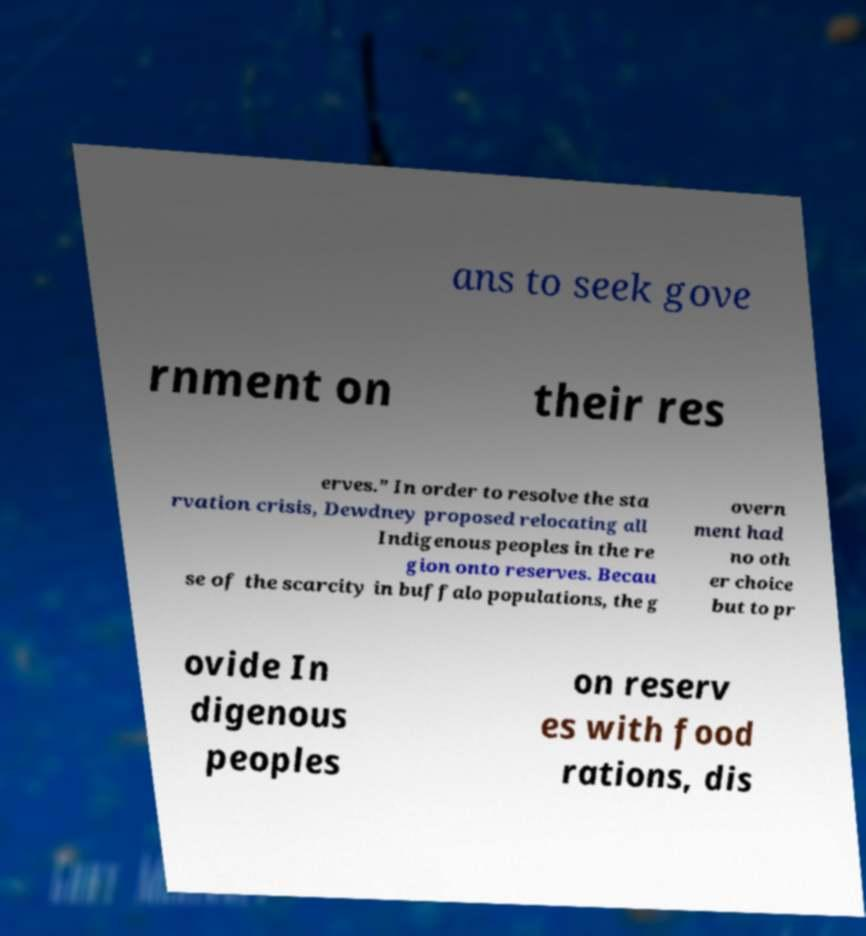Can you accurately transcribe the text from the provided image for me? ans to seek gove rnment on their res erves.” In order to resolve the sta rvation crisis, Dewdney proposed relocating all Indigenous peoples in the re gion onto reserves. Becau se of the scarcity in buffalo populations, the g overn ment had no oth er choice but to pr ovide In digenous peoples on reserv es with food rations, dis 